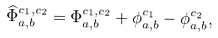Convert formula to latex. <formula><loc_0><loc_0><loc_500><loc_500>\widehat { \Phi } _ { a , b } ^ { c _ { 1 } , c _ { 2 } } = \Phi _ { a , b } ^ { c _ { 1 } , c _ { 2 } } + \phi _ { a , b } ^ { c _ { 1 } } - \phi _ { a , b } ^ { c _ { 2 } } ,</formula> 